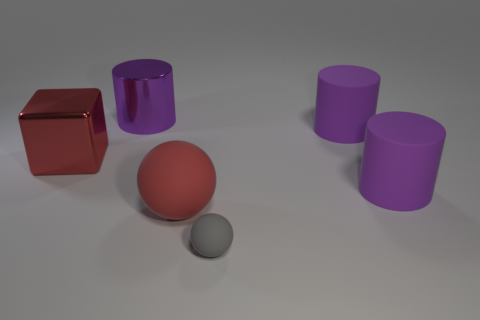Subtract all purple metal cylinders. How many cylinders are left? 2 Add 3 purple objects. How many objects exist? 9 Subtract all gray balls. How many balls are left? 1 Subtract all balls. How many objects are left? 4 Subtract all yellow cylinders. Subtract all yellow blocks. How many cylinders are left? 3 Subtract all brown cubes. How many gray balls are left? 1 Subtract all big red matte cubes. Subtract all large red things. How many objects are left? 4 Add 2 big balls. How many big balls are left? 3 Add 5 large cylinders. How many large cylinders exist? 8 Subtract 0 brown blocks. How many objects are left? 6 